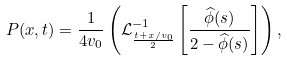<formula> <loc_0><loc_0><loc_500><loc_500>P ( x , t ) & = \frac { 1 } { 4 v _ { 0 } } \left ( \mathcal { L } ^ { - 1 } _ { \frac { t + x / v _ { 0 } } { 2 } } \left [ \frac { \widehat { \phi } ( s ) } { 2 - \widehat { \phi } ( s ) } \right ] \right ) , \\</formula> 